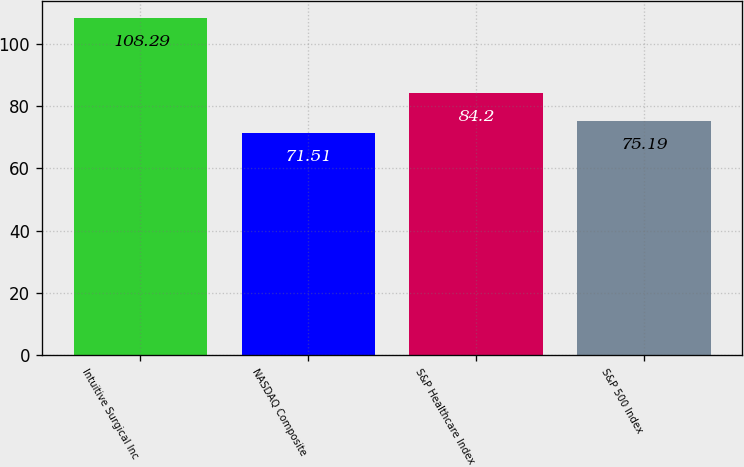<chart> <loc_0><loc_0><loc_500><loc_500><bar_chart><fcel>Intuitive Surgical Inc<fcel>NASDAQ Composite<fcel>S&P Healthcare Index<fcel>S&P 500 Index<nl><fcel>108.29<fcel>71.51<fcel>84.2<fcel>75.19<nl></chart> 